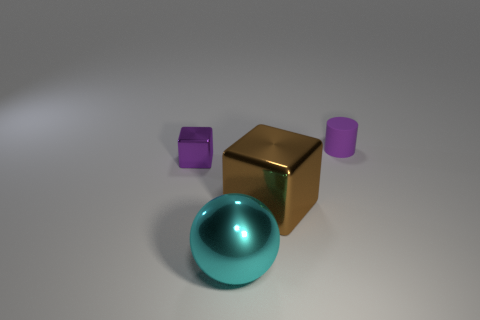What materials are represented by the objects in the scene? There are three different materials represented by the objects in the scene. The small and tall purple objects seem to be made of a matte finish plastic, the golden cube has a reflective metallic surface, and the spherical object has a glossy, transparent appearance similar to glass. 